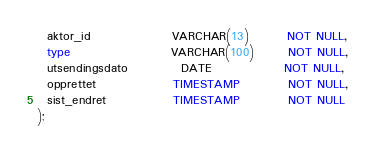Convert code to text. <code><loc_0><loc_0><loc_500><loc_500><_SQL_>  aktor_id                 VARCHAR(13)        NOT NULL,
  type                     VARCHAR(100)       NOT NULL,
  utsendingsdato           DATE               NOT NULL,
  opprettet                TIMESTAMP          NOT NULL,
  sist_endret              TIMESTAMP          NOT NULL
);
</code> 